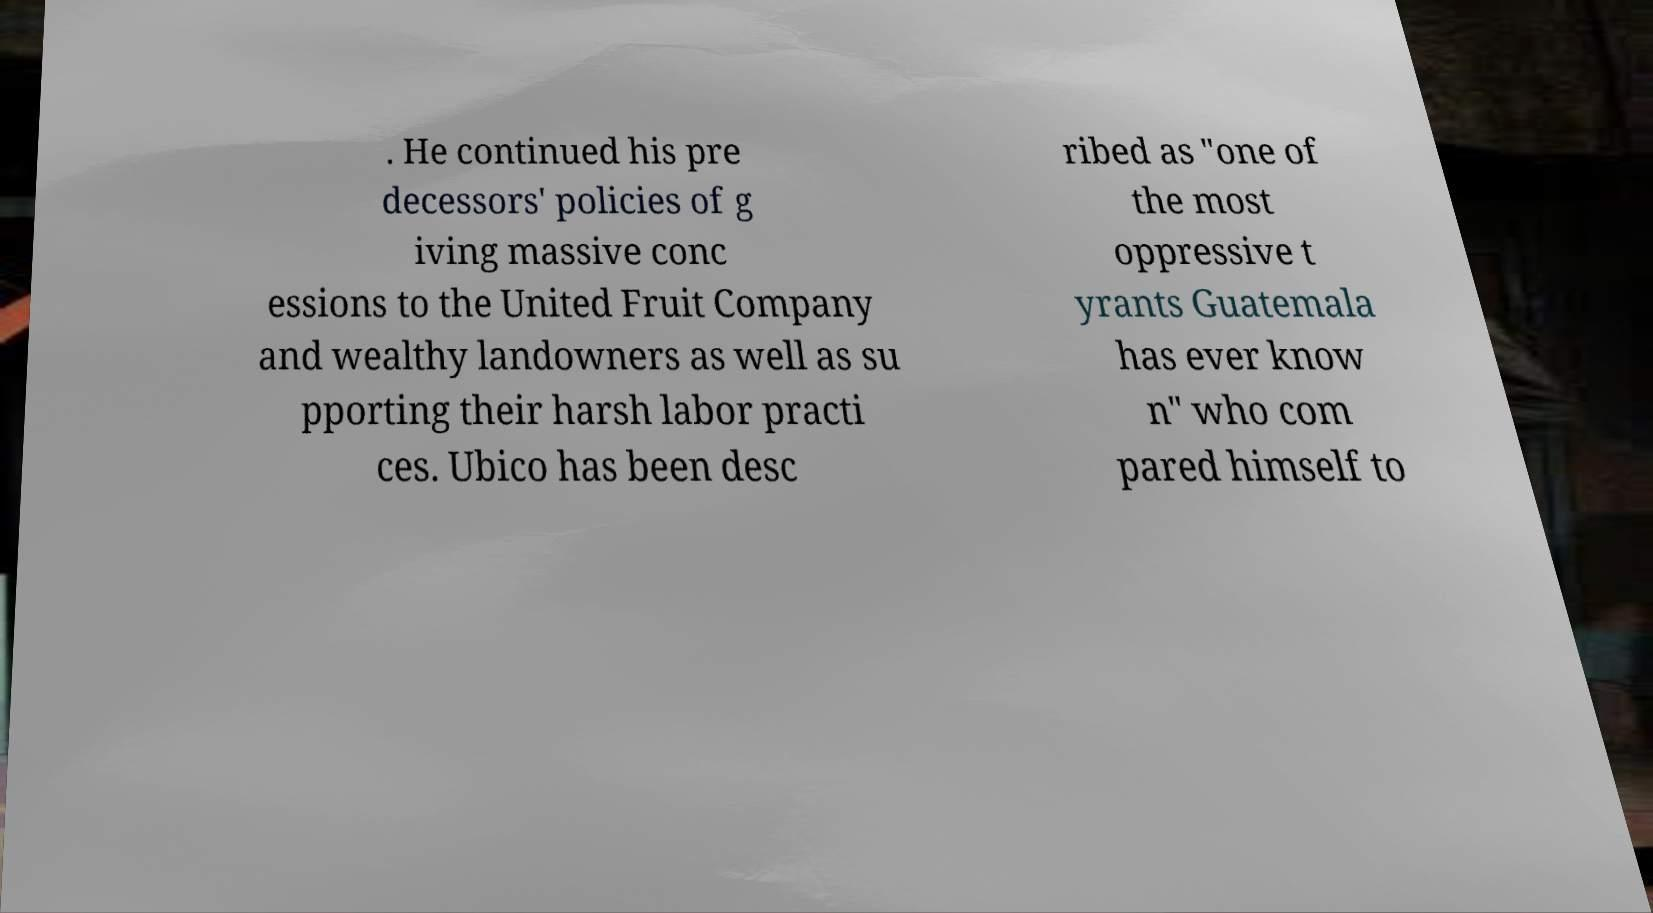I need the written content from this picture converted into text. Can you do that? . He continued his pre decessors' policies of g iving massive conc essions to the United Fruit Company and wealthy landowners as well as su pporting their harsh labor practi ces. Ubico has been desc ribed as "one of the most oppressive t yrants Guatemala has ever know n" who com pared himself to 